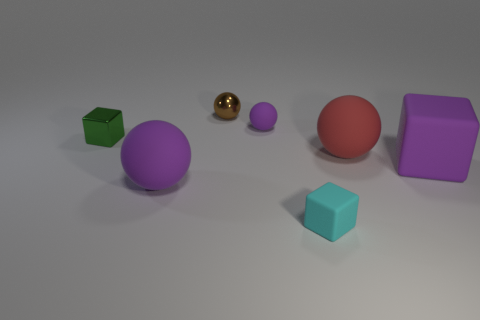Is there a green metallic object of the same shape as the red rubber thing?
Keep it short and to the point. No. There is a cube that is the same size as the red sphere; what is its color?
Give a very brief answer. Purple. How many objects are either big matte objects that are on the left side of the large red matte object or purple balls in front of the tiny metal block?
Your answer should be compact. 1. How many objects are either big yellow rubber cylinders or tiny blocks?
Your answer should be very brief. 2. There is a cube that is on the left side of the large red ball and behind the small matte block; how big is it?
Your answer should be very brief. Small. What number of small cyan things have the same material as the red sphere?
Your answer should be very brief. 1. What is the color of the large block that is made of the same material as the big purple sphere?
Keep it short and to the point. Purple. There is a shiny thing that is to the right of the green thing; is its color the same as the small matte cube?
Offer a very short reply. No. What is the large object to the left of the red matte ball made of?
Your answer should be compact. Rubber. Are there an equal number of blocks that are left of the tiny cyan rubber object and large blue cylinders?
Provide a short and direct response. No. 